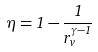<formula> <loc_0><loc_0><loc_500><loc_500>\eta = 1 - \frac { 1 } { r _ { v } ^ { \gamma - 1 } }</formula> 